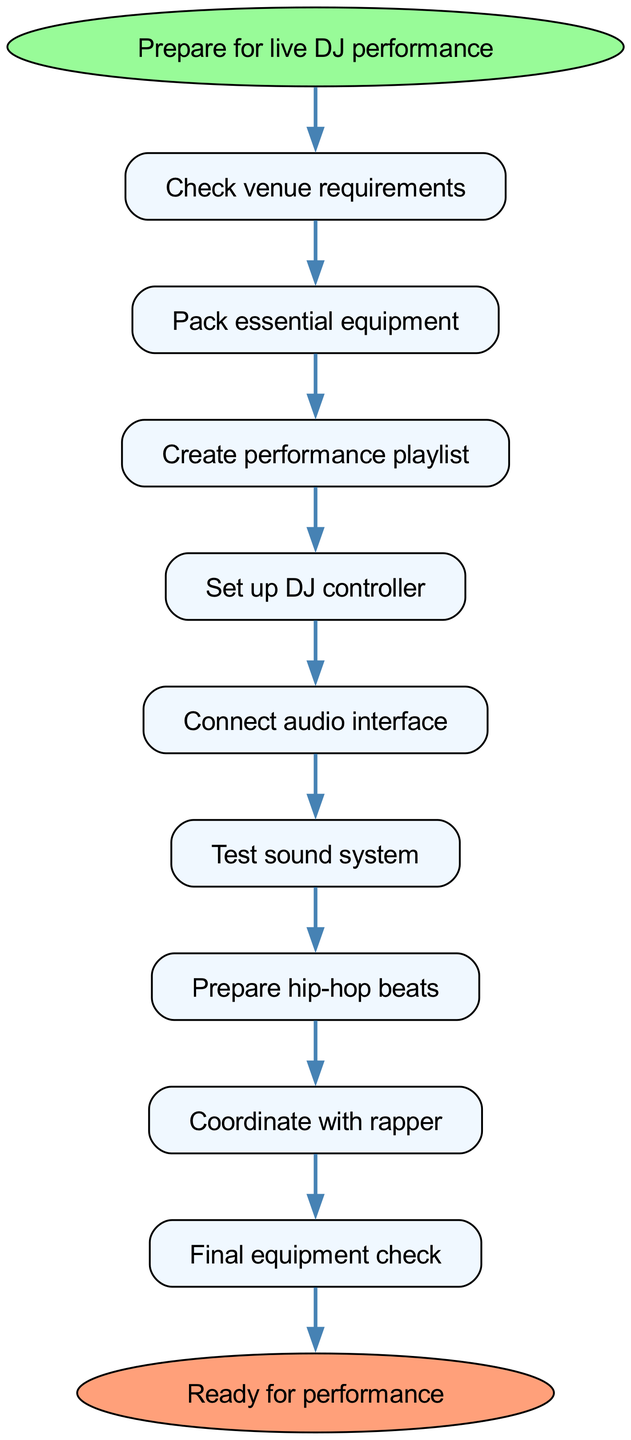What is the first step in preparing for a live DJ performance? The diagram starts with the node labeled "Prepare for live DJ performance," and the first action step is "Check venue requirements," which is the immediate next step in the flow.
Answer: Check venue requirements How many steps are listed in the preparation process? The diagram lists a total of 9 individual action steps from checking venue requirements to the final equipment check. This includes each distinct action in the list provided in the steps.
Answer: 9 What is the final action before being ready for the performance? According to the flow, the last action before reaching the "Ready for performance" endpoint is "Final equipment check," which is the last step in the sequence.
Answer: Final equipment check Which action directly follows "Create performance playlist"? Linked in the sequence, "Set up DJ controller" is the next node that comes after "Create performance playlist," indicating the flow of operations to be performed.
Answer: Set up DJ controller What is the relationship between "Prepare hip-hop beats" and "Coordinate with rapper"? The diagram shows that "Prepare hip-hop beats" is directly connected to "Coordinate with rapper," indicating that the preparation of beats is a precursor step before coordinating with the rapper for the performance.
Answer: Direct connection Which equipment is set up right after creating the performance playlist? The "Set up DJ controller" step immediately follows the "Create performance playlist" step in the sequence, indicating that setting up the DJ controller is the next action to be taken after playlist creation.
Answer: Set up DJ controller What is the purpose of "Test sound system" in the preparation process? In the flow chart, "Test sound system" serves as a critical step positioned after "Connect audio interface" and before "Prepare hip-hop beats," ensuring that the audio setup is functioning correctly before proceeding with the performance preparation.
Answer: Ensure audio functionality What step should be taken after "Connect audio interface"? According to the flow, the next action after "Connect audio interface" is "Test sound system," indicating that the system needs to be tested after all the relevant connections are made.
Answer: Test sound system 